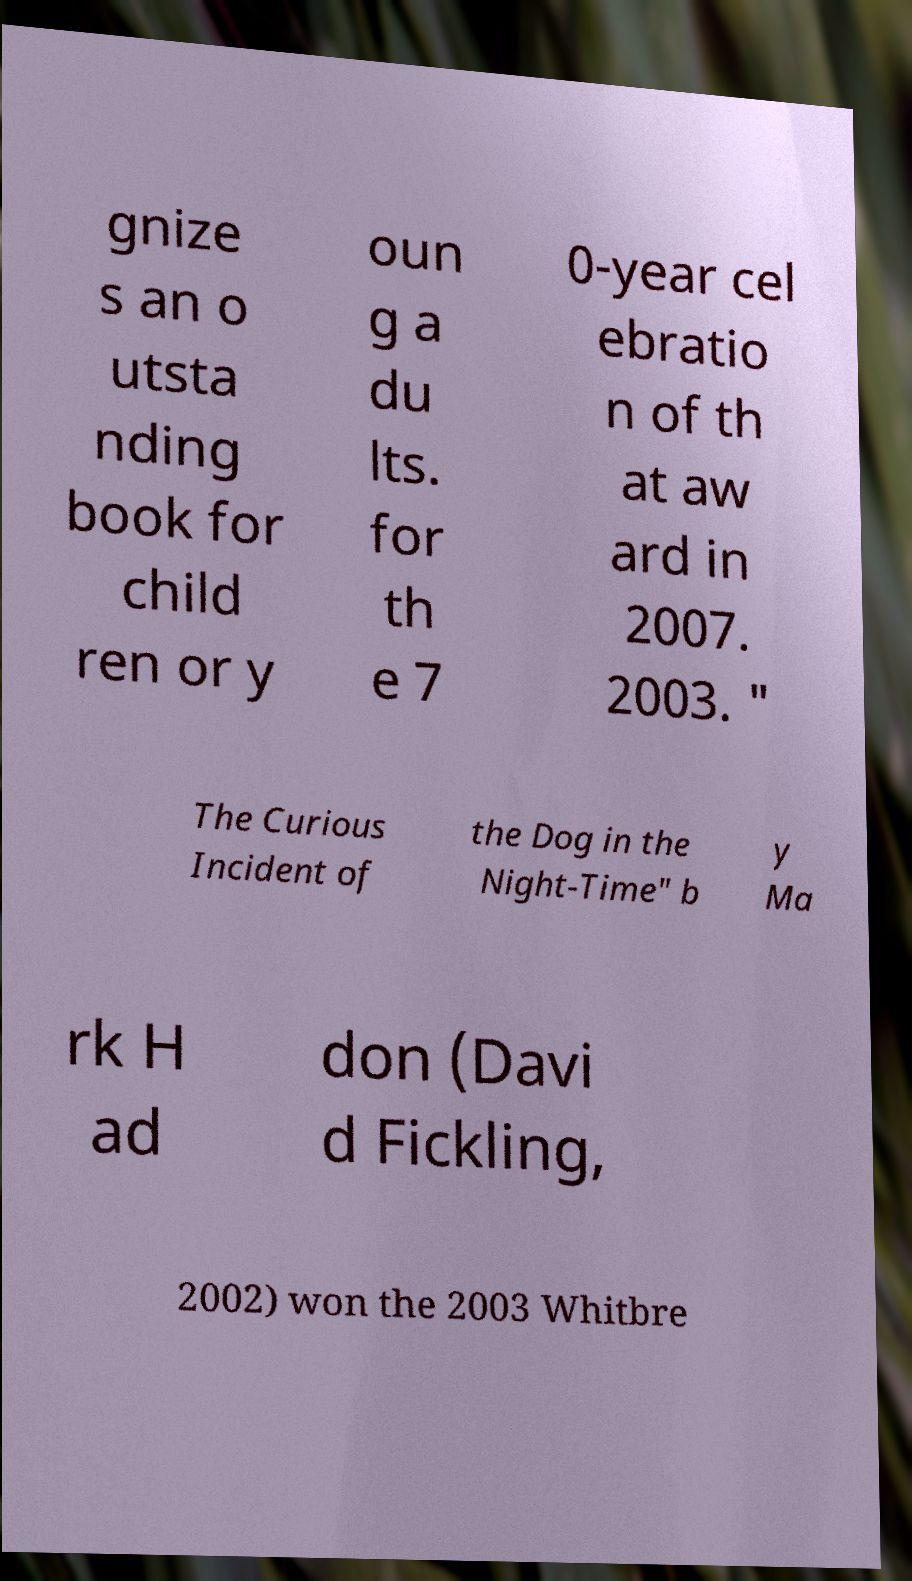There's text embedded in this image that I need extracted. Can you transcribe it verbatim? gnize s an o utsta nding book for child ren or y oun g a du lts. for th e 7 0-year cel ebratio n of th at aw ard in 2007. 2003. " The Curious Incident of the Dog in the Night-Time" b y Ma rk H ad don (Davi d Fickling, 2002) won the 2003 Whitbre 